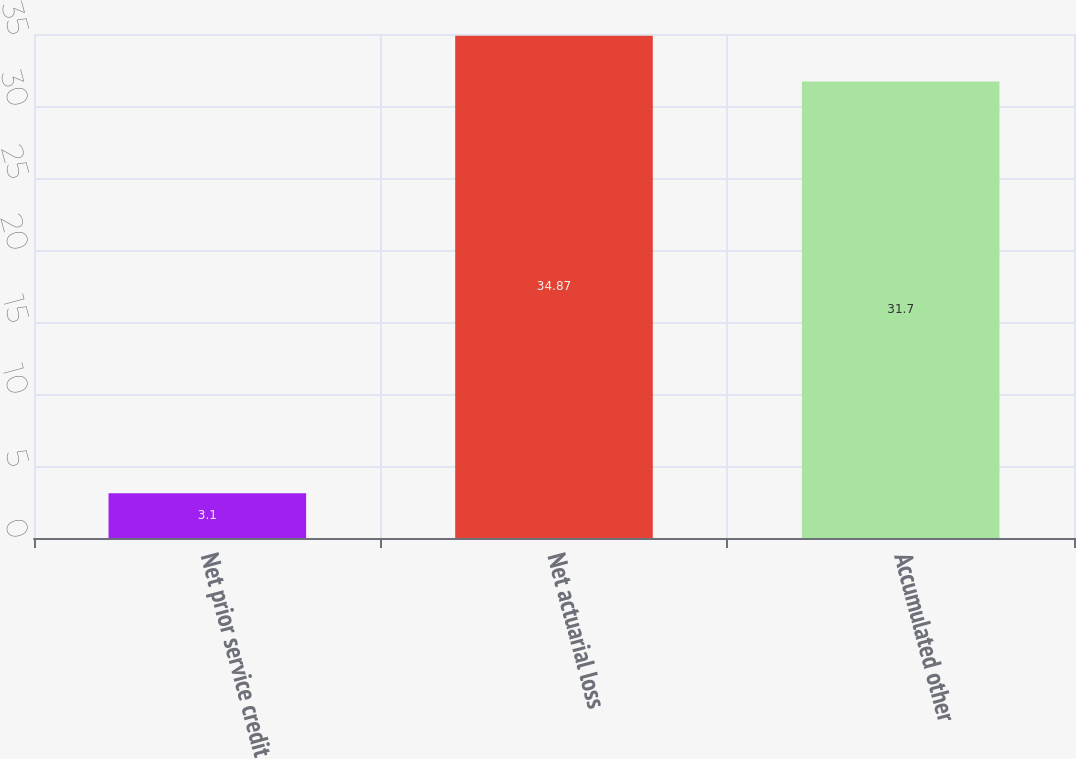Convert chart to OTSL. <chart><loc_0><loc_0><loc_500><loc_500><bar_chart><fcel>Net prior service credit<fcel>Net actuarial loss<fcel>Accumulated other<nl><fcel>3.1<fcel>34.87<fcel>31.7<nl></chart> 